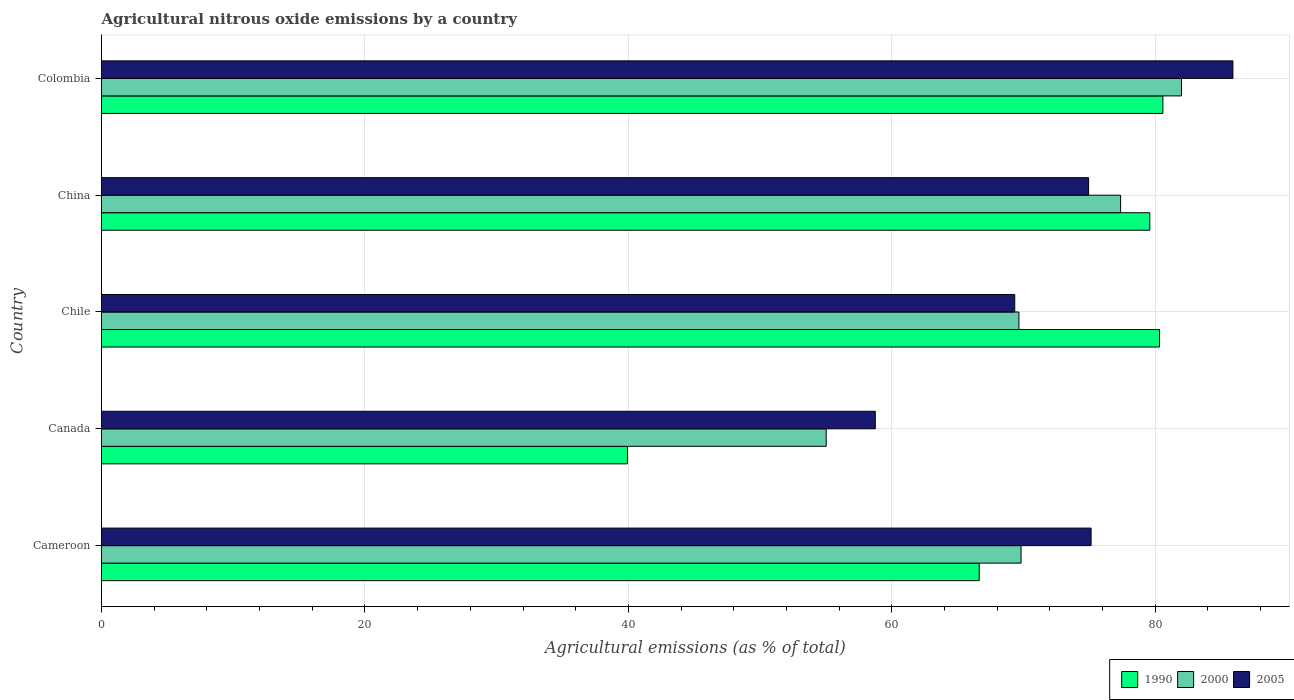How many different coloured bars are there?
Provide a short and direct response. 3. Are the number of bars on each tick of the Y-axis equal?
Give a very brief answer. Yes. What is the label of the 3rd group of bars from the top?
Provide a short and direct response. Chile. In how many cases, is the number of bars for a given country not equal to the number of legend labels?
Your response must be concise. 0. What is the amount of agricultural nitrous oxide emitted in 1990 in Cameroon?
Your answer should be compact. 66.63. Across all countries, what is the maximum amount of agricultural nitrous oxide emitted in 2000?
Make the answer very short. 81.99. Across all countries, what is the minimum amount of agricultural nitrous oxide emitted in 2005?
Your response must be concise. 58.75. In which country was the amount of agricultural nitrous oxide emitted in 2000 maximum?
Offer a terse response. Colombia. What is the total amount of agricultural nitrous oxide emitted in 2000 in the graph?
Give a very brief answer. 353.83. What is the difference between the amount of agricultural nitrous oxide emitted in 2000 in Cameroon and that in China?
Offer a terse response. -7.56. What is the difference between the amount of agricultural nitrous oxide emitted in 2000 in China and the amount of agricultural nitrous oxide emitted in 1990 in Chile?
Give a very brief answer. -2.96. What is the average amount of agricultural nitrous oxide emitted in 2005 per country?
Provide a succinct answer. 72.81. What is the difference between the amount of agricultural nitrous oxide emitted in 2000 and amount of agricultural nitrous oxide emitted in 1990 in Canada?
Ensure brevity in your answer.  15.09. What is the ratio of the amount of agricultural nitrous oxide emitted in 2000 in China to that in Colombia?
Keep it short and to the point. 0.94. What is the difference between the highest and the second highest amount of agricultural nitrous oxide emitted in 1990?
Your response must be concise. 0.26. What is the difference between the highest and the lowest amount of agricultural nitrous oxide emitted in 2005?
Provide a succinct answer. 27.15. What does the 1st bar from the bottom in Cameroon represents?
Your answer should be very brief. 1990. How many bars are there?
Make the answer very short. 15. Are the values on the major ticks of X-axis written in scientific E-notation?
Your answer should be compact. No. Does the graph contain any zero values?
Offer a very short reply. No. Where does the legend appear in the graph?
Give a very brief answer. Bottom right. How are the legend labels stacked?
Your response must be concise. Horizontal. What is the title of the graph?
Provide a short and direct response. Agricultural nitrous oxide emissions by a country. What is the label or title of the X-axis?
Your answer should be compact. Agricultural emissions (as % of total). What is the Agricultural emissions (as % of total) of 1990 in Cameroon?
Ensure brevity in your answer.  66.63. What is the Agricultural emissions (as % of total) of 2000 in Cameroon?
Give a very brief answer. 69.81. What is the Agricultural emissions (as % of total) of 2005 in Cameroon?
Provide a succinct answer. 75.13. What is the Agricultural emissions (as % of total) in 1990 in Canada?
Offer a terse response. 39.93. What is the Agricultural emissions (as % of total) of 2000 in Canada?
Your response must be concise. 55.02. What is the Agricultural emissions (as % of total) of 2005 in Canada?
Give a very brief answer. 58.75. What is the Agricultural emissions (as % of total) of 1990 in Chile?
Give a very brief answer. 80.32. What is the Agricultural emissions (as % of total) of 2000 in Chile?
Your response must be concise. 69.65. What is the Agricultural emissions (as % of total) in 2005 in Chile?
Give a very brief answer. 69.33. What is the Agricultural emissions (as % of total) of 1990 in China?
Your response must be concise. 79.59. What is the Agricultural emissions (as % of total) of 2000 in China?
Give a very brief answer. 77.37. What is the Agricultural emissions (as % of total) in 2005 in China?
Ensure brevity in your answer.  74.94. What is the Agricultural emissions (as % of total) of 1990 in Colombia?
Offer a terse response. 80.58. What is the Agricultural emissions (as % of total) of 2000 in Colombia?
Make the answer very short. 81.99. What is the Agricultural emissions (as % of total) of 2005 in Colombia?
Offer a very short reply. 85.89. Across all countries, what is the maximum Agricultural emissions (as % of total) in 1990?
Provide a short and direct response. 80.58. Across all countries, what is the maximum Agricultural emissions (as % of total) in 2000?
Ensure brevity in your answer.  81.99. Across all countries, what is the maximum Agricultural emissions (as % of total) in 2005?
Provide a succinct answer. 85.89. Across all countries, what is the minimum Agricultural emissions (as % of total) in 1990?
Your answer should be compact. 39.93. Across all countries, what is the minimum Agricultural emissions (as % of total) in 2000?
Provide a succinct answer. 55.02. Across all countries, what is the minimum Agricultural emissions (as % of total) in 2005?
Your answer should be compact. 58.75. What is the total Agricultural emissions (as % of total) of 1990 in the graph?
Ensure brevity in your answer.  347.05. What is the total Agricultural emissions (as % of total) in 2000 in the graph?
Ensure brevity in your answer.  353.83. What is the total Agricultural emissions (as % of total) in 2005 in the graph?
Your response must be concise. 364.04. What is the difference between the Agricultural emissions (as % of total) of 1990 in Cameroon and that in Canada?
Your response must be concise. 26.7. What is the difference between the Agricultural emissions (as % of total) of 2000 in Cameroon and that in Canada?
Give a very brief answer. 14.79. What is the difference between the Agricultural emissions (as % of total) of 2005 in Cameroon and that in Canada?
Ensure brevity in your answer.  16.38. What is the difference between the Agricultural emissions (as % of total) in 1990 in Cameroon and that in Chile?
Make the answer very short. -13.69. What is the difference between the Agricultural emissions (as % of total) in 2000 in Cameroon and that in Chile?
Your response must be concise. 0.16. What is the difference between the Agricultural emissions (as % of total) in 2005 in Cameroon and that in Chile?
Keep it short and to the point. 5.8. What is the difference between the Agricultural emissions (as % of total) of 1990 in Cameroon and that in China?
Provide a succinct answer. -12.95. What is the difference between the Agricultural emissions (as % of total) of 2000 in Cameroon and that in China?
Your response must be concise. -7.56. What is the difference between the Agricultural emissions (as % of total) of 2005 in Cameroon and that in China?
Make the answer very short. 0.19. What is the difference between the Agricultural emissions (as % of total) of 1990 in Cameroon and that in Colombia?
Make the answer very short. -13.94. What is the difference between the Agricultural emissions (as % of total) in 2000 in Cameroon and that in Colombia?
Ensure brevity in your answer.  -12.18. What is the difference between the Agricultural emissions (as % of total) of 2005 in Cameroon and that in Colombia?
Your response must be concise. -10.77. What is the difference between the Agricultural emissions (as % of total) in 1990 in Canada and that in Chile?
Offer a very short reply. -40.39. What is the difference between the Agricultural emissions (as % of total) of 2000 in Canada and that in Chile?
Provide a succinct answer. -14.63. What is the difference between the Agricultural emissions (as % of total) of 2005 in Canada and that in Chile?
Provide a short and direct response. -10.59. What is the difference between the Agricultural emissions (as % of total) of 1990 in Canada and that in China?
Make the answer very short. -39.66. What is the difference between the Agricultural emissions (as % of total) in 2000 in Canada and that in China?
Your answer should be very brief. -22.35. What is the difference between the Agricultural emissions (as % of total) of 2005 in Canada and that in China?
Give a very brief answer. -16.19. What is the difference between the Agricultural emissions (as % of total) in 1990 in Canada and that in Colombia?
Offer a very short reply. -40.65. What is the difference between the Agricultural emissions (as % of total) of 2000 in Canada and that in Colombia?
Make the answer very short. -26.97. What is the difference between the Agricultural emissions (as % of total) in 2005 in Canada and that in Colombia?
Your response must be concise. -27.15. What is the difference between the Agricultural emissions (as % of total) of 1990 in Chile and that in China?
Provide a succinct answer. 0.74. What is the difference between the Agricultural emissions (as % of total) in 2000 in Chile and that in China?
Make the answer very short. -7.72. What is the difference between the Agricultural emissions (as % of total) in 2005 in Chile and that in China?
Your answer should be compact. -5.61. What is the difference between the Agricultural emissions (as % of total) in 1990 in Chile and that in Colombia?
Make the answer very short. -0.26. What is the difference between the Agricultural emissions (as % of total) of 2000 in Chile and that in Colombia?
Your response must be concise. -12.34. What is the difference between the Agricultural emissions (as % of total) of 2005 in Chile and that in Colombia?
Make the answer very short. -16.56. What is the difference between the Agricultural emissions (as % of total) in 1990 in China and that in Colombia?
Give a very brief answer. -0.99. What is the difference between the Agricultural emissions (as % of total) in 2000 in China and that in Colombia?
Your response must be concise. -4.62. What is the difference between the Agricultural emissions (as % of total) of 2005 in China and that in Colombia?
Your answer should be very brief. -10.96. What is the difference between the Agricultural emissions (as % of total) of 1990 in Cameroon and the Agricultural emissions (as % of total) of 2000 in Canada?
Provide a succinct answer. 11.62. What is the difference between the Agricultural emissions (as % of total) of 1990 in Cameroon and the Agricultural emissions (as % of total) of 2005 in Canada?
Provide a succinct answer. 7.89. What is the difference between the Agricultural emissions (as % of total) in 2000 in Cameroon and the Agricultural emissions (as % of total) in 2005 in Canada?
Ensure brevity in your answer.  11.06. What is the difference between the Agricultural emissions (as % of total) in 1990 in Cameroon and the Agricultural emissions (as % of total) in 2000 in Chile?
Make the answer very short. -3.01. What is the difference between the Agricultural emissions (as % of total) of 1990 in Cameroon and the Agricultural emissions (as % of total) of 2005 in Chile?
Provide a succinct answer. -2.7. What is the difference between the Agricultural emissions (as % of total) of 2000 in Cameroon and the Agricultural emissions (as % of total) of 2005 in Chile?
Give a very brief answer. 0.48. What is the difference between the Agricultural emissions (as % of total) of 1990 in Cameroon and the Agricultural emissions (as % of total) of 2000 in China?
Offer a terse response. -10.73. What is the difference between the Agricultural emissions (as % of total) of 1990 in Cameroon and the Agricultural emissions (as % of total) of 2005 in China?
Give a very brief answer. -8.31. What is the difference between the Agricultural emissions (as % of total) in 2000 in Cameroon and the Agricultural emissions (as % of total) in 2005 in China?
Offer a terse response. -5.13. What is the difference between the Agricultural emissions (as % of total) in 1990 in Cameroon and the Agricultural emissions (as % of total) in 2000 in Colombia?
Make the answer very short. -15.36. What is the difference between the Agricultural emissions (as % of total) in 1990 in Cameroon and the Agricultural emissions (as % of total) in 2005 in Colombia?
Offer a very short reply. -19.26. What is the difference between the Agricultural emissions (as % of total) in 2000 in Cameroon and the Agricultural emissions (as % of total) in 2005 in Colombia?
Your answer should be compact. -16.08. What is the difference between the Agricultural emissions (as % of total) of 1990 in Canada and the Agricultural emissions (as % of total) of 2000 in Chile?
Your response must be concise. -29.72. What is the difference between the Agricultural emissions (as % of total) in 1990 in Canada and the Agricultural emissions (as % of total) in 2005 in Chile?
Offer a very short reply. -29.4. What is the difference between the Agricultural emissions (as % of total) in 2000 in Canada and the Agricultural emissions (as % of total) in 2005 in Chile?
Keep it short and to the point. -14.31. What is the difference between the Agricultural emissions (as % of total) of 1990 in Canada and the Agricultural emissions (as % of total) of 2000 in China?
Ensure brevity in your answer.  -37.44. What is the difference between the Agricultural emissions (as % of total) of 1990 in Canada and the Agricultural emissions (as % of total) of 2005 in China?
Your answer should be very brief. -35.01. What is the difference between the Agricultural emissions (as % of total) of 2000 in Canada and the Agricultural emissions (as % of total) of 2005 in China?
Make the answer very short. -19.92. What is the difference between the Agricultural emissions (as % of total) in 1990 in Canada and the Agricultural emissions (as % of total) in 2000 in Colombia?
Give a very brief answer. -42.06. What is the difference between the Agricultural emissions (as % of total) of 1990 in Canada and the Agricultural emissions (as % of total) of 2005 in Colombia?
Your answer should be very brief. -45.97. What is the difference between the Agricultural emissions (as % of total) in 2000 in Canada and the Agricultural emissions (as % of total) in 2005 in Colombia?
Make the answer very short. -30.88. What is the difference between the Agricultural emissions (as % of total) of 1990 in Chile and the Agricultural emissions (as % of total) of 2000 in China?
Your response must be concise. 2.96. What is the difference between the Agricultural emissions (as % of total) of 1990 in Chile and the Agricultural emissions (as % of total) of 2005 in China?
Ensure brevity in your answer.  5.38. What is the difference between the Agricultural emissions (as % of total) of 2000 in Chile and the Agricultural emissions (as % of total) of 2005 in China?
Ensure brevity in your answer.  -5.29. What is the difference between the Agricultural emissions (as % of total) of 1990 in Chile and the Agricultural emissions (as % of total) of 2000 in Colombia?
Your answer should be very brief. -1.67. What is the difference between the Agricultural emissions (as % of total) of 1990 in Chile and the Agricultural emissions (as % of total) of 2005 in Colombia?
Make the answer very short. -5.57. What is the difference between the Agricultural emissions (as % of total) in 2000 in Chile and the Agricultural emissions (as % of total) in 2005 in Colombia?
Offer a terse response. -16.25. What is the difference between the Agricultural emissions (as % of total) in 1990 in China and the Agricultural emissions (as % of total) in 2000 in Colombia?
Offer a terse response. -2.4. What is the difference between the Agricultural emissions (as % of total) in 1990 in China and the Agricultural emissions (as % of total) in 2005 in Colombia?
Make the answer very short. -6.31. What is the difference between the Agricultural emissions (as % of total) in 2000 in China and the Agricultural emissions (as % of total) in 2005 in Colombia?
Your answer should be compact. -8.53. What is the average Agricultural emissions (as % of total) in 1990 per country?
Give a very brief answer. 69.41. What is the average Agricultural emissions (as % of total) in 2000 per country?
Provide a short and direct response. 70.77. What is the average Agricultural emissions (as % of total) in 2005 per country?
Provide a short and direct response. 72.81. What is the difference between the Agricultural emissions (as % of total) in 1990 and Agricultural emissions (as % of total) in 2000 in Cameroon?
Your response must be concise. -3.18. What is the difference between the Agricultural emissions (as % of total) in 1990 and Agricultural emissions (as % of total) in 2005 in Cameroon?
Give a very brief answer. -8.49. What is the difference between the Agricultural emissions (as % of total) in 2000 and Agricultural emissions (as % of total) in 2005 in Cameroon?
Make the answer very short. -5.32. What is the difference between the Agricultural emissions (as % of total) in 1990 and Agricultural emissions (as % of total) in 2000 in Canada?
Your answer should be very brief. -15.09. What is the difference between the Agricultural emissions (as % of total) of 1990 and Agricultural emissions (as % of total) of 2005 in Canada?
Offer a very short reply. -18.82. What is the difference between the Agricultural emissions (as % of total) in 2000 and Agricultural emissions (as % of total) in 2005 in Canada?
Provide a short and direct response. -3.73. What is the difference between the Agricultural emissions (as % of total) of 1990 and Agricultural emissions (as % of total) of 2000 in Chile?
Keep it short and to the point. 10.67. What is the difference between the Agricultural emissions (as % of total) of 1990 and Agricultural emissions (as % of total) of 2005 in Chile?
Ensure brevity in your answer.  10.99. What is the difference between the Agricultural emissions (as % of total) of 2000 and Agricultural emissions (as % of total) of 2005 in Chile?
Keep it short and to the point. 0.32. What is the difference between the Agricultural emissions (as % of total) in 1990 and Agricultural emissions (as % of total) in 2000 in China?
Your answer should be very brief. 2.22. What is the difference between the Agricultural emissions (as % of total) in 1990 and Agricultural emissions (as % of total) in 2005 in China?
Offer a terse response. 4.65. What is the difference between the Agricultural emissions (as % of total) of 2000 and Agricultural emissions (as % of total) of 2005 in China?
Provide a succinct answer. 2.43. What is the difference between the Agricultural emissions (as % of total) of 1990 and Agricultural emissions (as % of total) of 2000 in Colombia?
Your answer should be very brief. -1.41. What is the difference between the Agricultural emissions (as % of total) of 1990 and Agricultural emissions (as % of total) of 2005 in Colombia?
Offer a very short reply. -5.32. What is the difference between the Agricultural emissions (as % of total) in 2000 and Agricultural emissions (as % of total) in 2005 in Colombia?
Your response must be concise. -3.9. What is the ratio of the Agricultural emissions (as % of total) of 1990 in Cameroon to that in Canada?
Your response must be concise. 1.67. What is the ratio of the Agricultural emissions (as % of total) of 2000 in Cameroon to that in Canada?
Your answer should be very brief. 1.27. What is the ratio of the Agricultural emissions (as % of total) in 2005 in Cameroon to that in Canada?
Your response must be concise. 1.28. What is the ratio of the Agricultural emissions (as % of total) in 1990 in Cameroon to that in Chile?
Offer a terse response. 0.83. What is the ratio of the Agricultural emissions (as % of total) of 2000 in Cameroon to that in Chile?
Provide a short and direct response. 1. What is the ratio of the Agricultural emissions (as % of total) of 2005 in Cameroon to that in Chile?
Give a very brief answer. 1.08. What is the ratio of the Agricultural emissions (as % of total) of 1990 in Cameroon to that in China?
Provide a succinct answer. 0.84. What is the ratio of the Agricultural emissions (as % of total) in 2000 in Cameroon to that in China?
Offer a terse response. 0.9. What is the ratio of the Agricultural emissions (as % of total) in 2005 in Cameroon to that in China?
Keep it short and to the point. 1. What is the ratio of the Agricultural emissions (as % of total) of 1990 in Cameroon to that in Colombia?
Keep it short and to the point. 0.83. What is the ratio of the Agricultural emissions (as % of total) in 2000 in Cameroon to that in Colombia?
Keep it short and to the point. 0.85. What is the ratio of the Agricultural emissions (as % of total) of 2005 in Cameroon to that in Colombia?
Provide a succinct answer. 0.87. What is the ratio of the Agricultural emissions (as % of total) of 1990 in Canada to that in Chile?
Offer a terse response. 0.5. What is the ratio of the Agricultural emissions (as % of total) of 2000 in Canada to that in Chile?
Offer a very short reply. 0.79. What is the ratio of the Agricultural emissions (as % of total) of 2005 in Canada to that in Chile?
Your answer should be compact. 0.85. What is the ratio of the Agricultural emissions (as % of total) of 1990 in Canada to that in China?
Ensure brevity in your answer.  0.5. What is the ratio of the Agricultural emissions (as % of total) in 2000 in Canada to that in China?
Offer a terse response. 0.71. What is the ratio of the Agricultural emissions (as % of total) in 2005 in Canada to that in China?
Offer a very short reply. 0.78. What is the ratio of the Agricultural emissions (as % of total) in 1990 in Canada to that in Colombia?
Keep it short and to the point. 0.5. What is the ratio of the Agricultural emissions (as % of total) of 2000 in Canada to that in Colombia?
Provide a short and direct response. 0.67. What is the ratio of the Agricultural emissions (as % of total) in 2005 in Canada to that in Colombia?
Your response must be concise. 0.68. What is the ratio of the Agricultural emissions (as % of total) of 1990 in Chile to that in China?
Provide a short and direct response. 1.01. What is the ratio of the Agricultural emissions (as % of total) of 2000 in Chile to that in China?
Give a very brief answer. 0.9. What is the ratio of the Agricultural emissions (as % of total) of 2005 in Chile to that in China?
Your response must be concise. 0.93. What is the ratio of the Agricultural emissions (as % of total) in 2000 in Chile to that in Colombia?
Offer a terse response. 0.85. What is the ratio of the Agricultural emissions (as % of total) of 2005 in Chile to that in Colombia?
Give a very brief answer. 0.81. What is the ratio of the Agricultural emissions (as % of total) in 2000 in China to that in Colombia?
Offer a terse response. 0.94. What is the ratio of the Agricultural emissions (as % of total) in 2005 in China to that in Colombia?
Provide a succinct answer. 0.87. What is the difference between the highest and the second highest Agricultural emissions (as % of total) of 1990?
Your answer should be compact. 0.26. What is the difference between the highest and the second highest Agricultural emissions (as % of total) in 2000?
Offer a terse response. 4.62. What is the difference between the highest and the second highest Agricultural emissions (as % of total) in 2005?
Give a very brief answer. 10.77. What is the difference between the highest and the lowest Agricultural emissions (as % of total) in 1990?
Ensure brevity in your answer.  40.65. What is the difference between the highest and the lowest Agricultural emissions (as % of total) in 2000?
Give a very brief answer. 26.97. What is the difference between the highest and the lowest Agricultural emissions (as % of total) of 2005?
Provide a succinct answer. 27.15. 